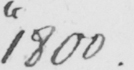Please provide the text content of this handwritten line. " 1800 . 